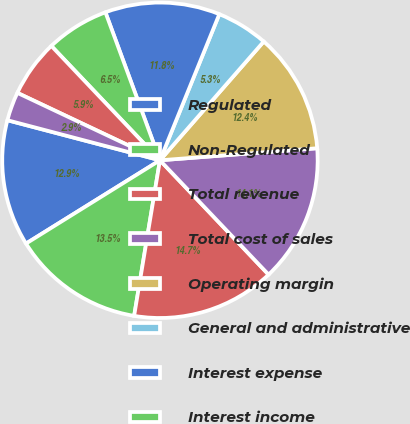Convert chart to OTSL. <chart><loc_0><loc_0><loc_500><loc_500><pie_chart><fcel>Regulated<fcel>Non-Regulated<fcel>Total revenue<fcel>Total cost of sales<fcel>Operating margin<fcel>General and administrative<fcel>Interest expense<fcel>Interest income<fcel>Loss on extinguishment of debt<fcel>Other expense<nl><fcel>12.94%<fcel>13.53%<fcel>14.71%<fcel>14.12%<fcel>12.35%<fcel>5.29%<fcel>11.76%<fcel>6.47%<fcel>5.88%<fcel>2.94%<nl></chart> 